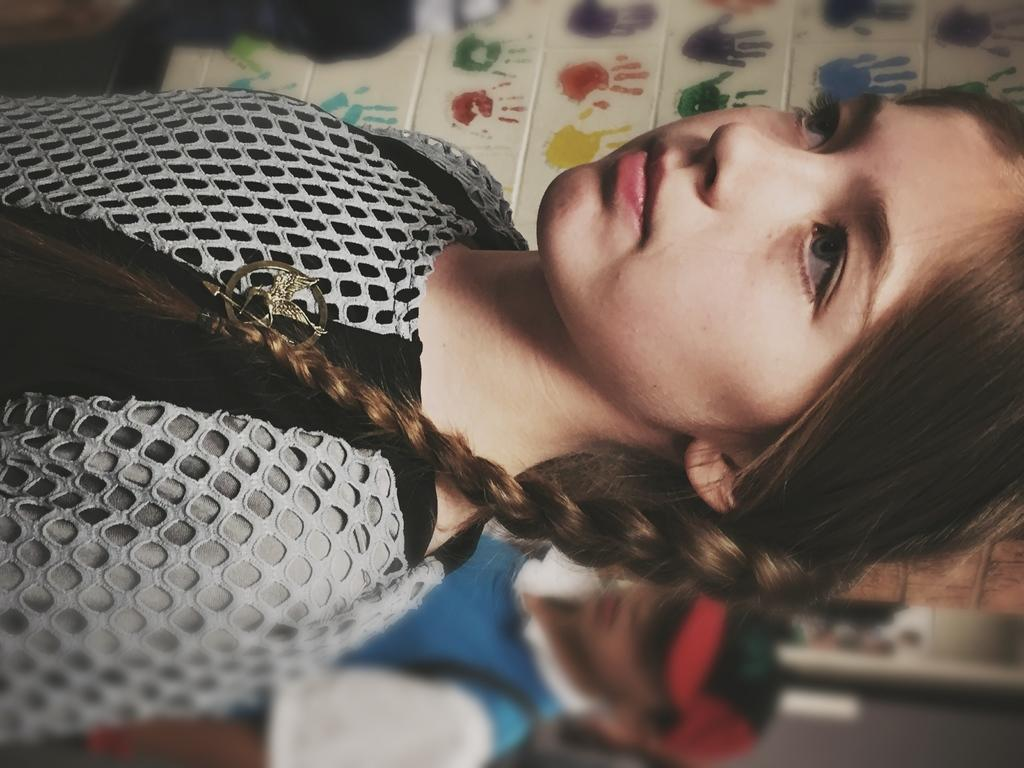Who is the main subject in the image? There is a girl in the image. Can you describe the person behind the girl? There is another person behind the girl. What can be seen in the background of the image? There is a wall with fingerprints in the background of the image. Is it raining in the image? There is no indication of rain in the image; it only shows a girl, another person, and a wall with fingerprints. 